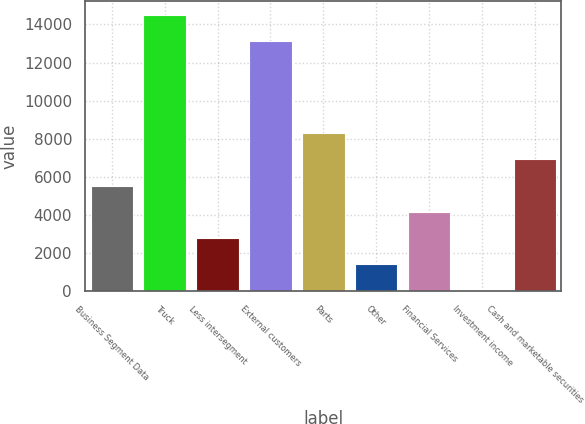Convert chart to OTSL. <chart><loc_0><loc_0><loc_500><loc_500><bar_chart><fcel>Business Segment Data<fcel>Truck<fcel>Less intersegment<fcel>External customers<fcel>Parts<fcel>Other<fcel>Financial Services<fcel>Investment income<fcel>Cash and marketable securities<nl><fcel>5538.7<fcel>14507.9<fcel>2785.9<fcel>13131.5<fcel>8291.5<fcel>1409.5<fcel>4162.3<fcel>33.1<fcel>6915.1<nl></chart> 